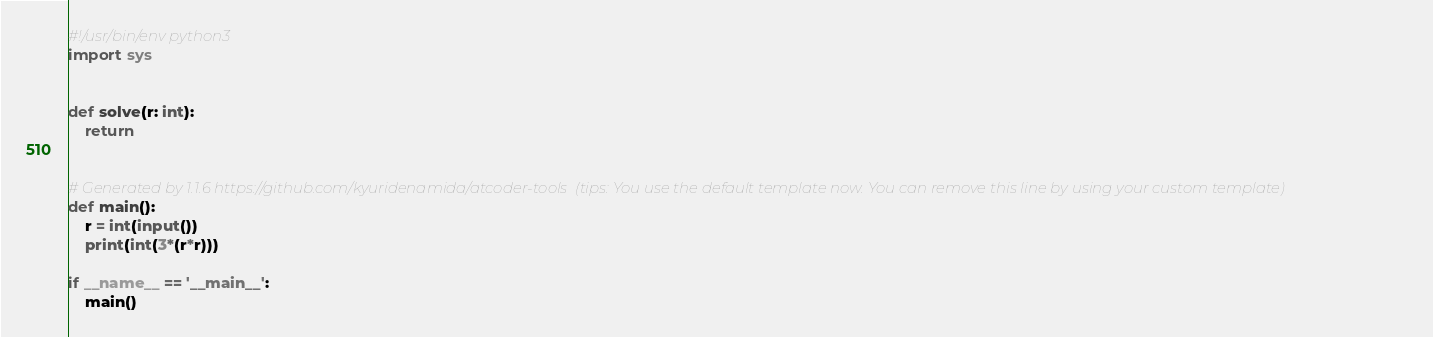Convert code to text. <code><loc_0><loc_0><loc_500><loc_500><_Python_>#!/usr/bin/env python3
import sys


def solve(r: int):
    return


# Generated by 1.1.6 https://github.com/kyuridenamida/atcoder-tools  (tips: You use the default template now. You can remove this line by using your custom template)
def main():
    r = int(input())
    print(int(3*(r*r)))

if __name__ == '__main__':
    main()
</code> 